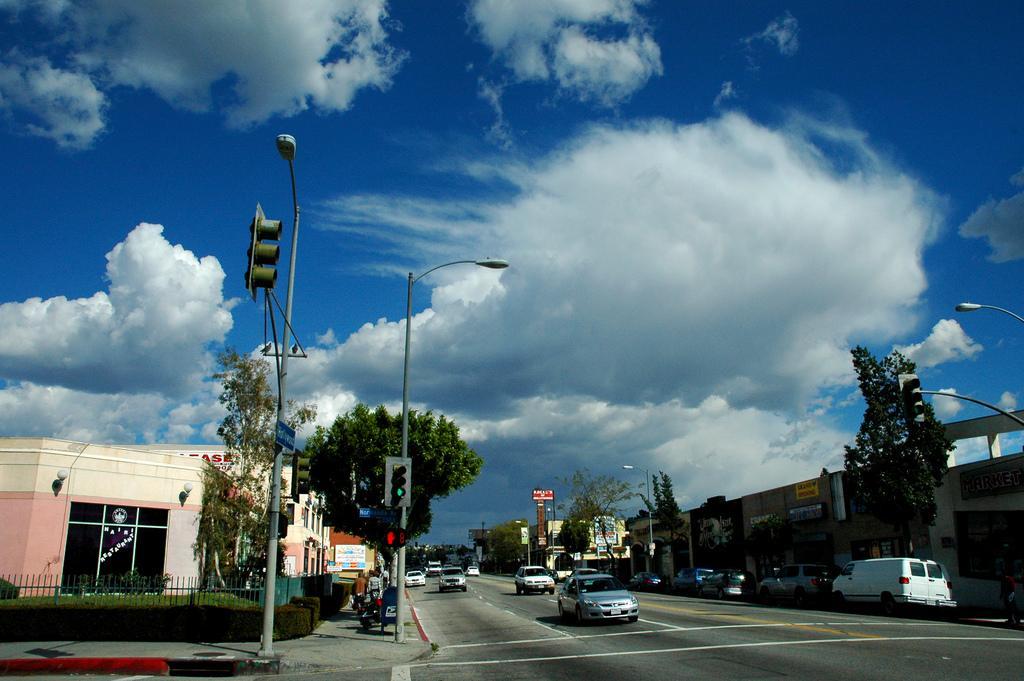In one or two sentences, can you explain what this image depicts? In this picture I can see the building, poles, street lights, traffic signals, boards and road. On the road I can see the cars, van and vehicles. On the left I can see the plants and fencing. At the top I can see the sky and clouds. 